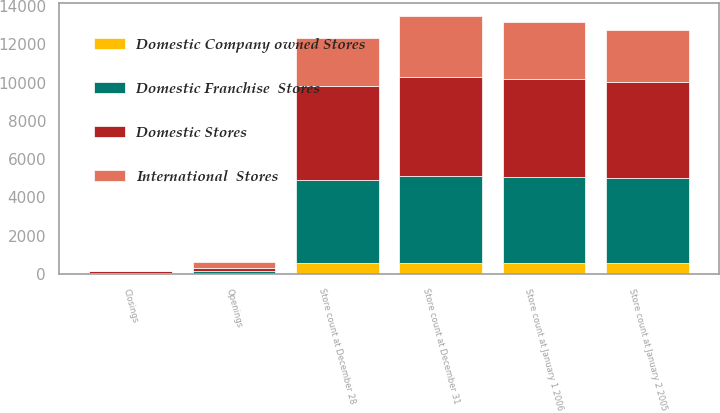Convert chart. <chart><loc_0><loc_0><loc_500><loc_500><stacked_bar_chart><ecel><fcel>Store count at December 28<fcel>Openings<fcel>Closings<fcel>Store count at January 2 2005<fcel>Store count at January 1 2006<fcel>Store count at December 31<nl><fcel>Domestic Company owned Stores<fcel>577<fcel>5<fcel>1<fcel>580<fcel>581<fcel>571<nl><fcel>Domestic Franchise  Stores<fcel>4327<fcel>165<fcel>65<fcel>4428<fcel>4511<fcel>4572<nl><fcel>Domestic Stores<fcel>4904<fcel>170<fcel>66<fcel>5008<fcel>5092<fcel>5143<nl><fcel>International  Stores<fcel>2523<fcel>263<fcel>37<fcel>2749<fcel>2987<fcel>3223<nl></chart> 